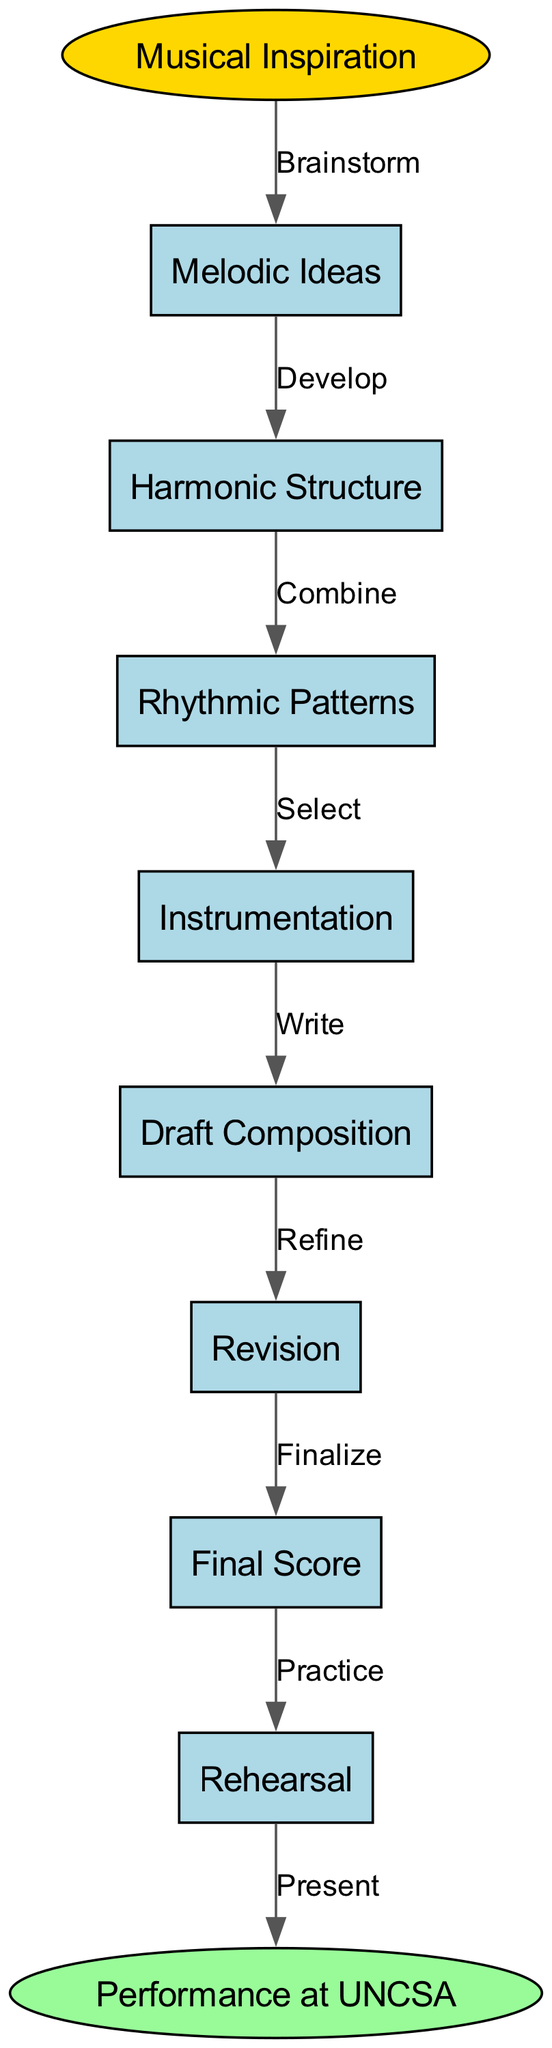What is the first step in the music composition process? The first step in the process is "Musical Inspiration," which is represented at the top of the diagram.
Answer: Musical Inspiration How many total nodes are in the diagram? The diagram contains ten nodes, which can be counted from the list provided in the diagram.
Answer: 10 What is the last step before the final performance? The last step before the final performance is "Rehearsal," which comes right before the "Performance at UNCSA" node.
Answer: Rehearsal Which two steps combine melodic ideas and rhythmic patterns? The steps that involve combining melodic ideas and rhythmic patterns are "Combine," which connects the nodes for "Melodic Ideas" and "Rhythmic Patterns" to the next step in the process.
Answer: Combine What is the relationship between "Draft Composition" and "Revision"? The relationship between "Draft Composition" and "Revision" is indicated by the label "Refine," showing that refining is the process of making revisions based on the draft.
Answer: Refine Which step directly follows "Harmonic Structure"? The step that directly follows "Harmonic Structure" is "Rhythmic Patterns," as indicated by the flow of the diagram.
Answer: Rhythmic Patterns What is the immediate predecessor of "Final Score"? The immediate predecessor of "Final Score" is "Revision," as it connects to the final score as the last step of refinement.
Answer: Revision What type of diagram is used to represent the music composition process? The diagram used is a flowchart, which illustrates the sequential steps involved in the music composition process.
Answer: Flowchart 